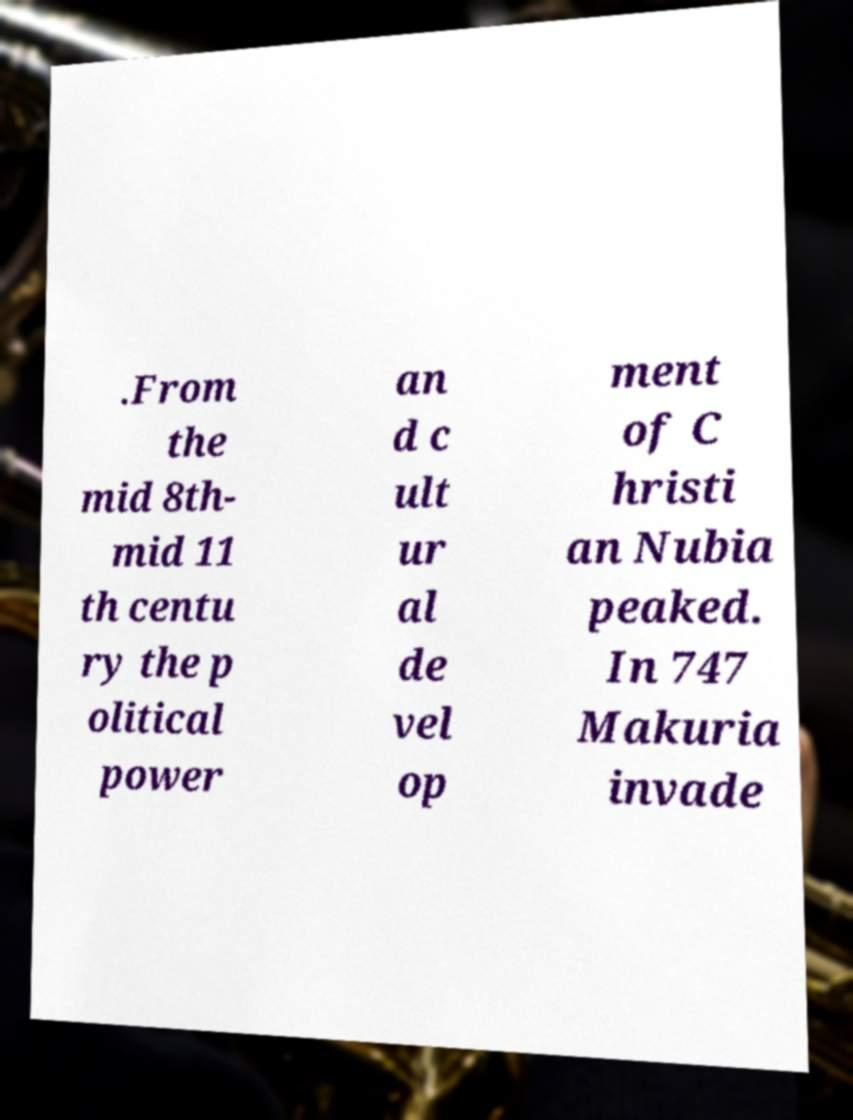I need the written content from this picture converted into text. Can you do that? .From the mid 8th- mid 11 th centu ry the p olitical power an d c ult ur al de vel op ment of C hristi an Nubia peaked. In 747 Makuria invade 